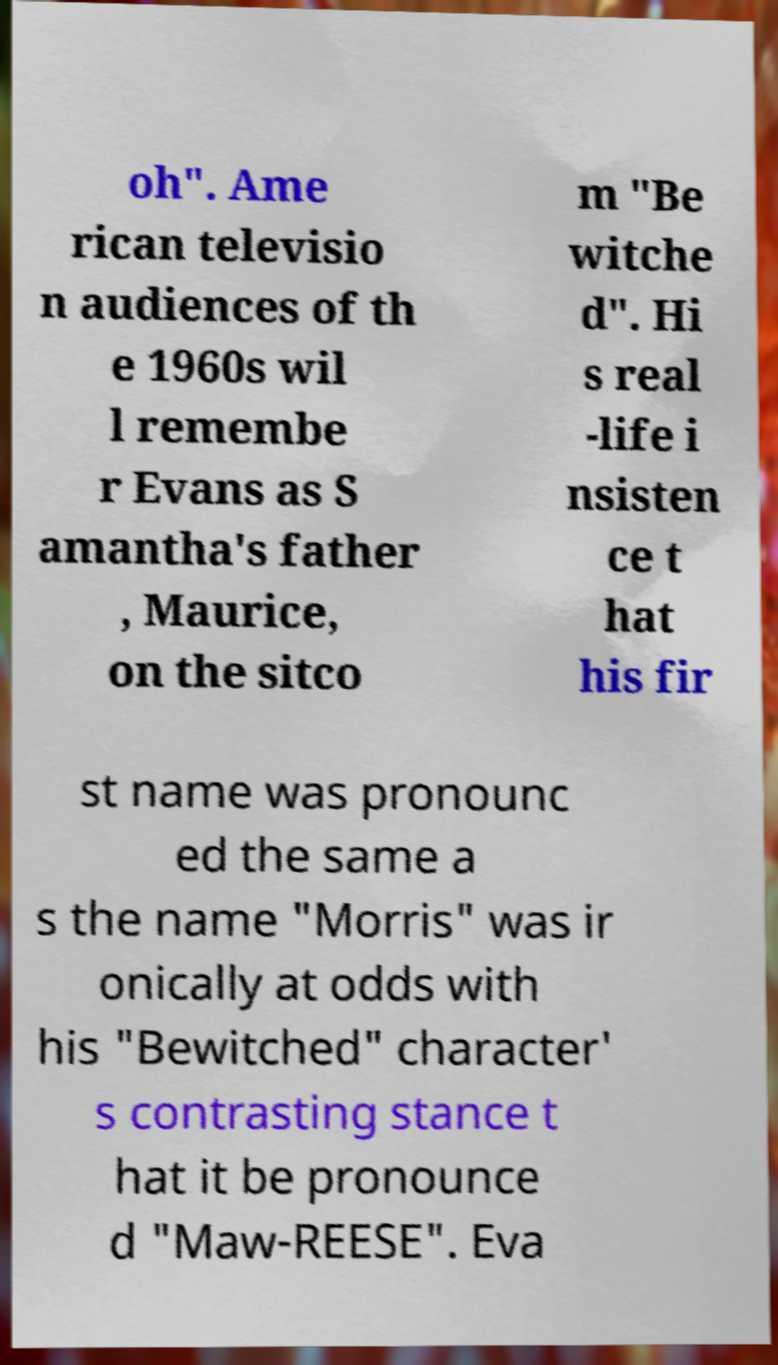There's text embedded in this image that I need extracted. Can you transcribe it verbatim? oh". Ame rican televisio n audiences of th e 1960s wil l remembe r Evans as S amantha's father , Maurice, on the sitco m "Be witche d". Hi s real -life i nsisten ce t hat his fir st name was pronounc ed the same a s the name "Morris" was ir onically at odds with his "Bewitched" character' s contrasting stance t hat it be pronounce d "Maw-REESE". Eva 